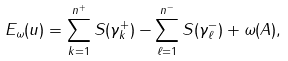<formula> <loc_0><loc_0><loc_500><loc_500>E _ { \omega } ( u ) = \sum _ { k = 1 } ^ { n ^ { + } } S ( \gamma _ { k } ^ { + } ) - \sum _ { \ell = 1 } ^ { n ^ { - } } S ( \gamma _ { \ell } ^ { - } ) + \omega ( A ) ,</formula> 